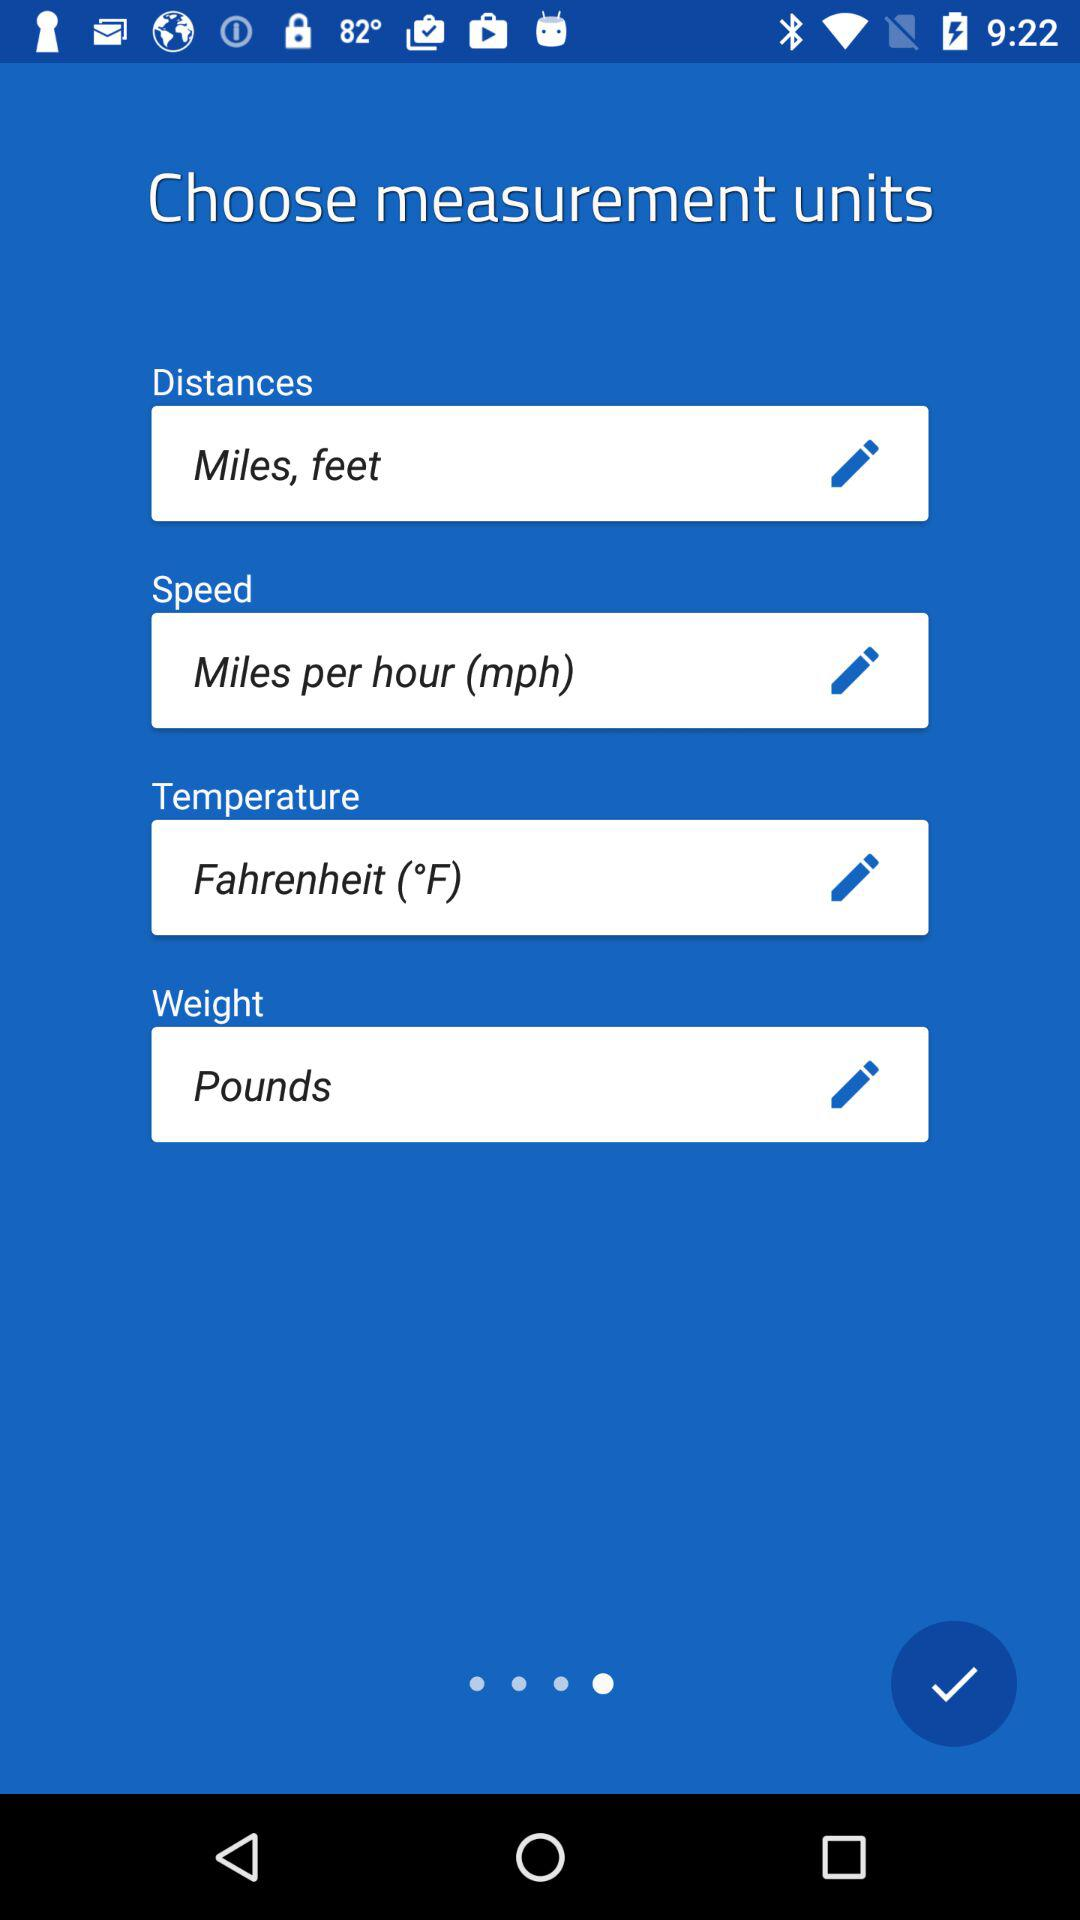What is the unit of measurement for speed? The unit of measurement for speed is miles per hour (mph). 